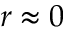Convert formula to latex. <formula><loc_0><loc_0><loc_500><loc_500>r \approx 0</formula> 